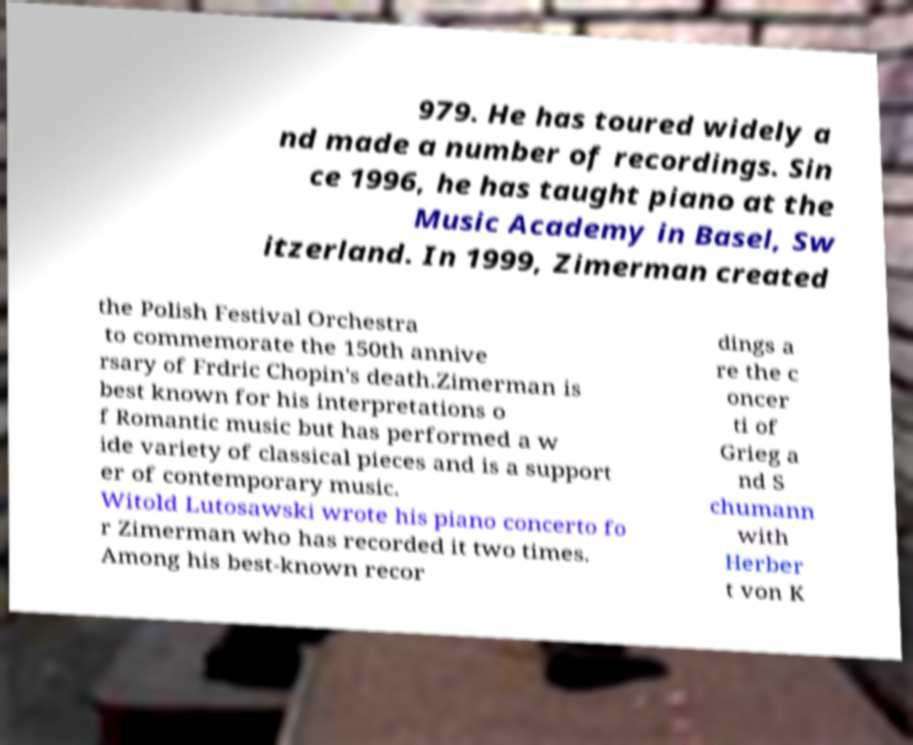What messages or text are displayed in this image? I need them in a readable, typed format. 979. He has toured widely a nd made a number of recordings. Sin ce 1996, he has taught piano at the Music Academy in Basel, Sw itzerland. In 1999, Zimerman created the Polish Festival Orchestra to commemorate the 150th annive rsary of Frdric Chopin's death.Zimerman is best known for his interpretations o f Romantic music but has performed a w ide variety of classical pieces and is a support er of contemporary music. Witold Lutosawski wrote his piano concerto fo r Zimerman who has recorded it two times. Among his best-known recor dings a re the c oncer ti of Grieg a nd S chumann with Herber t von K 